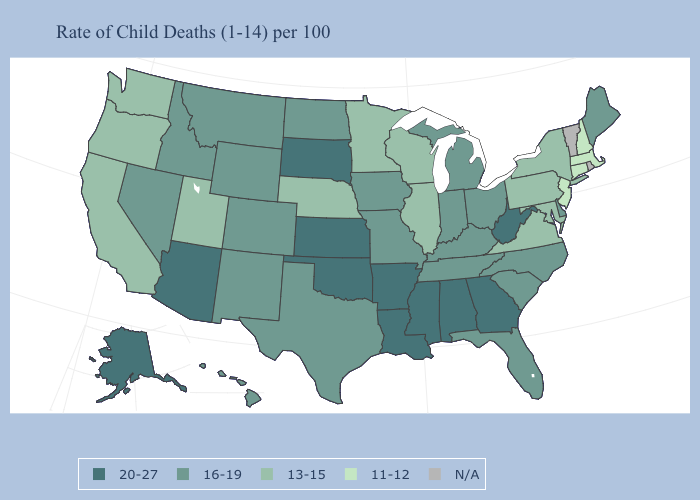What is the value of Virginia?
Quick response, please. 13-15. What is the highest value in the USA?
Concise answer only. 20-27. Does Kansas have the highest value in the USA?
Write a very short answer. Yes. Does Michigan have the highest value in the USA?
Write a very short answer. No. Which states have the lowest value in the South?
Quick response, please. Maryland, Virginia. Does the first symbol in the legend represent the smallest category?
Answer briefly. No. Does North Carolina have the highest value in the South?
Answer briefly. No. What is the value of Washington?
Keep it brief. 13-15. What is the value of Iowa?
Quick response, please. 16-19. What is the value of North Dakota?
Concise answer only. 16-19. Which states have the highest value in the USA?
Concise answer only. Alabama, Alaska, Arizona, Arkansas, Georgia, Kansas, Louisiana, Mississippi, Oklahoma, South Dakota, West Virginia. Does Maine have the highest value in the Northeast?
Answer briefly. Yes. Name the states that have a value in the range 16-19?
Keep it brief. Colorado, Delaware, Florida, Hawaii, Idaho, Indiana, Iowa, Kentucky, Maine, Michigan, Missouri, Montana, Nevada, New Mexico, North Carolina, North Dakota, Ohio, South Carolina, Tennessee, Texas, Wyoming. Is the legend a continuous bar?
Answer briefly. No. 